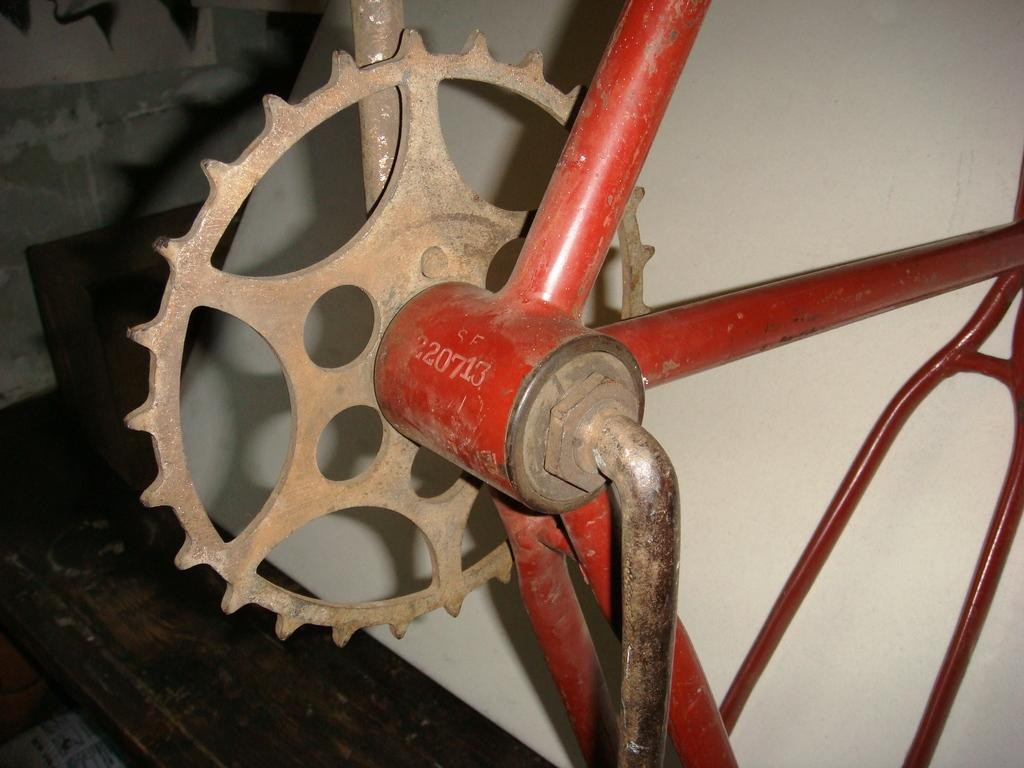What is the main object in the image? There is an equipment in the image. What colors can be seen on the equipment? The equipment is brown and red in color. Is there any text on the equipment? Yes, there is text written on the equipment. What can be seen beneath the equipment? The floor is visible in the image. What is visible behind the equipment? There is a wall in the background of the image. What type of prose is being read by the equipment in the image? There is no indication in the image that the equipment is reading any prose, as it is an inanimate object. 